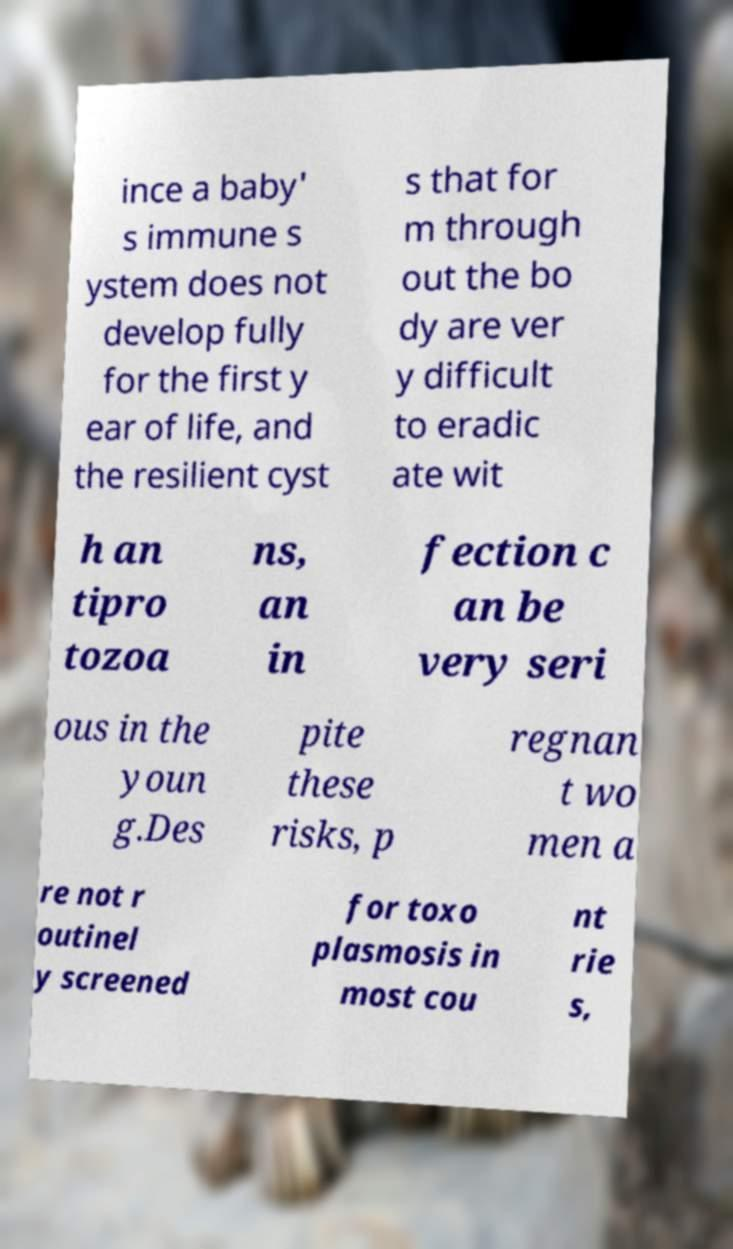Please identify and transcribe the text found in this image. ince a baby' s immune s ystem does not develop fully for the first y ear of life, and the resilient cyst s that for m through out the bo dy are ver y difficult to eradic ate wit h an tipro tozoa ns, an in fection c an be very seri ous in the youn g.Des pite these risks, p regnan t wo men a re not r outinel y screened for toxo plasmosis in most cou nt rie s, 